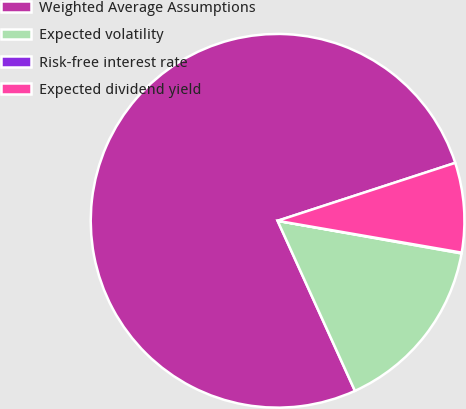Convert chart. <chart><loc_0><loc_0><loc_500><loc_500><pie_chart><fcel>Weighted Average Assumptions<fcel>Expected volatility<fcel>Risk-free interest rate<fcel>Expected dividend yield<nl><fcel>76.77%<fcel>15.41%<fcel>0.07%<fcel>7.74%<nl></chart> 